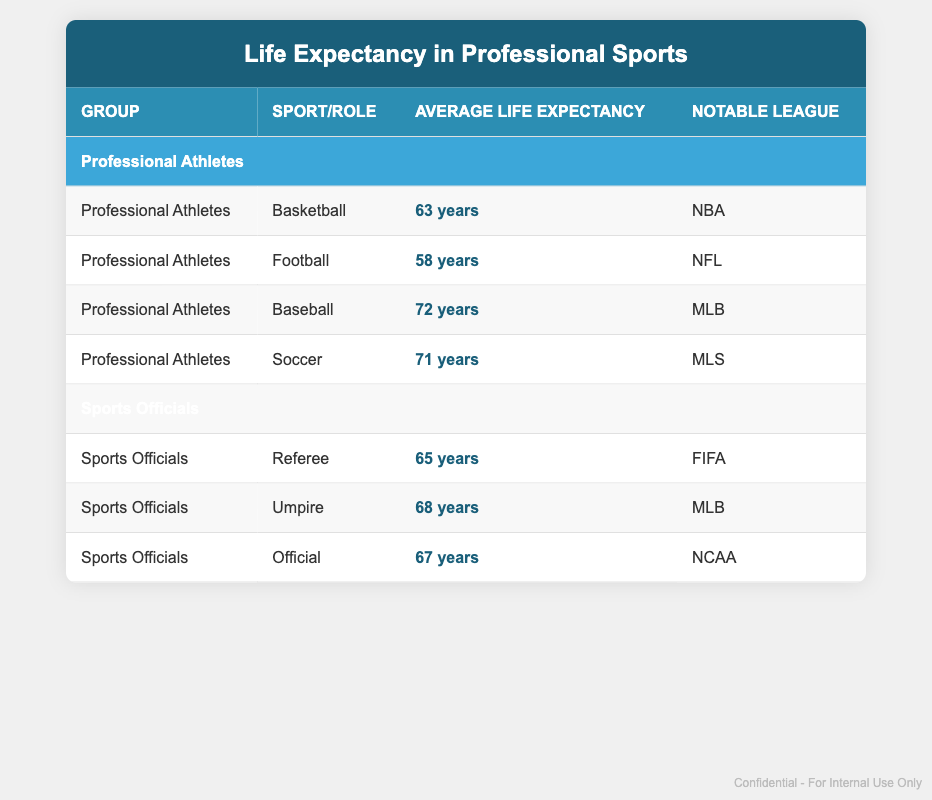What is the average life expectancy of professional athletes? To find the average, we take the life expectancies of all professional athletes listed in the table: 63 (Basketball) + 58 (Football) + 72 (Baseball) + 71 (Soccer) = 264. There are 4 athletes, so the average is 264 / 4 = 66 years.
Answer: 66 years What is the life expectancy of umpires compared to referees? The average life expectancy of umpires is 68 years (listed as Sports Officials, Umpire) and referees is 65 years (listed as Sports Officials, Referee). Comparing these values shows that umpires have a longer life expectancy by 3 years.
Answer: Umpires have a life expectancy of 3 years longer Which sport has the lowest life expectancy for professional athletes? From the data provided, Football has the lowest life expectancy at 58 years (listed as Professional Athletes, Football).
Answer: Football has the lowest life expectancy Is the average life expectancy of sports officials higher than that of professional athletes? The average life expectancy of sports officials is calculated as follows: (65 for Referees + 68 for Umpires + 67 for Officials) = 200, and there are 3 officials, so the average is 200 / 3 = 66.67 years. The average life expectancy of professional athletes is 66 years, thus the average for sports officials is slightly higher than that of professional athletes.
Answer: Yes, officials have a higher average life expectancy Which notable league has the highest life expectancy among the groups presented? We first gather the life expectancies tied to notable leagues: NBA (63), NFL (58), MLB (72 for Baseball and 68 for Umpires), MLS (71), and FIFA (65). The highest among these is MLB with 72 years from Baseball.
Answer: MLB has the highest life expectancy 